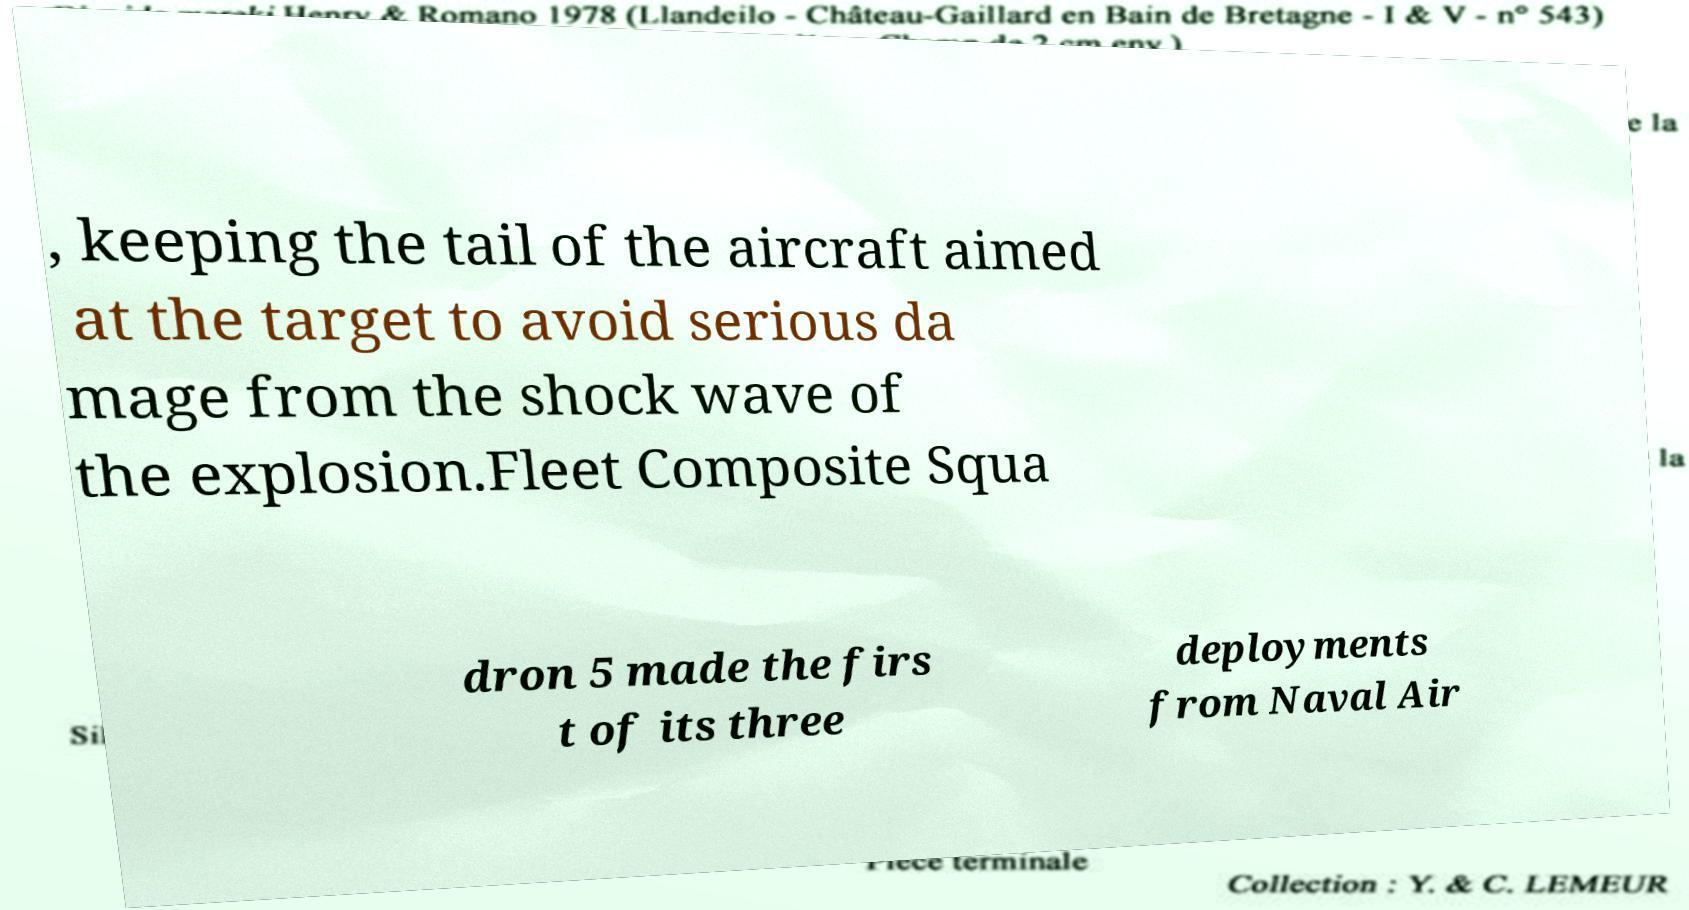What messages or text are displayed in this image? I need them in a readable, typed format. , keeping the tail of the aircraft aimed at the target to avoid serious da mage from the shock wave of the explosion.Fleet Composite Squa dron 5 made the firs t of its three deployments from Naval Air 